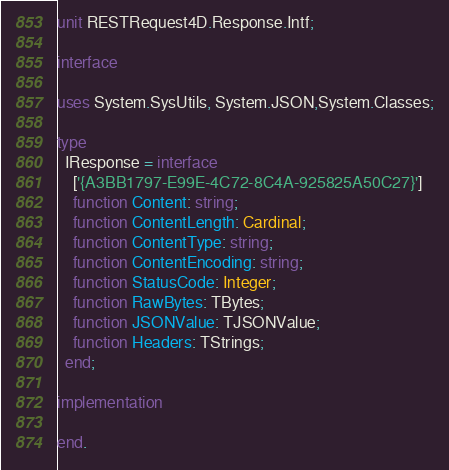<code> <loc_0><loc_0><loc_500><loc_500><_Pascal_>unit RESTRequest4D.Response.Intf;

interface

uses System.SysUtils, System.JSON,System.Classes;

type
  IResponse = interface
    ['{A3BB1797-E99E-4C72-8C4A-925825A50C27}']
    function Content: string;
    function ContentLength: Cardinal;
    function ContentType: string;
    function ContentEncoding: string;
    function StatusCode: Integer;
    function RawBytes: TBytes;
    function JSONValue: TJSONValue;
    function Headers: TStrings;
  end;

implementation

end.
</code> 